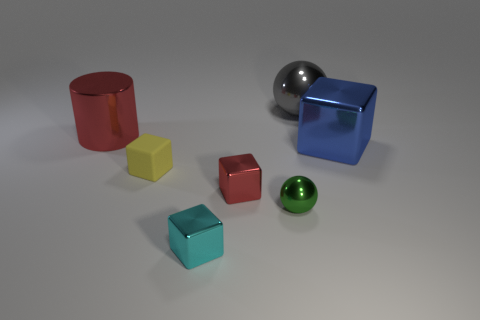Subtract 1 cubes. How many cubes are left? 3 Subtract all gray blocks. Subtract all gray cylinders. How many blocks are left? 4 Add 1 big yellow shiny cylinders. How many objects exist? 8 Subtract all cylinders. How many objects are left? 6 Subtract 0 purple cylinders. How many objects are left? 7 Subtract all cyan rubber cylinders. Subtract all gray metal objects. How many objects are left? 6 Add 6 gray metal objects. How many gray metal objects are left? 7 Add 2 small yellow blocks. How many small yellow blocks exist? 3 